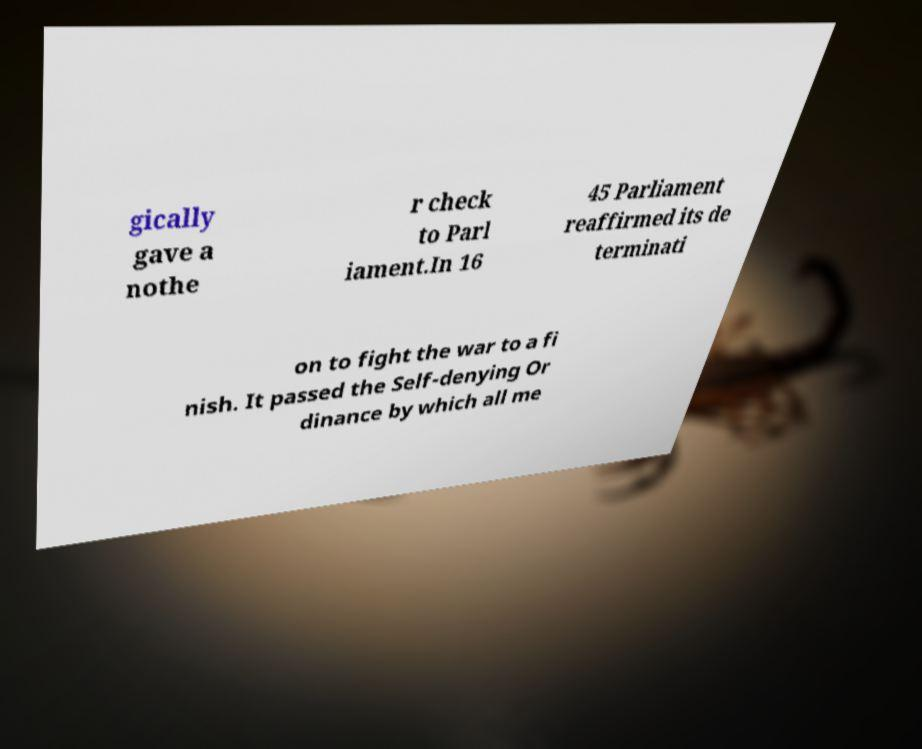For documentation purposes, I need the text within this image transcribed. Could you provide that? gically gave a nothe r check to Parl iament.In 16 45 Parliament reaffirmed its de terminati on to fight the war to a fi nish. It passed the Self-denying Or dinance by which all me 